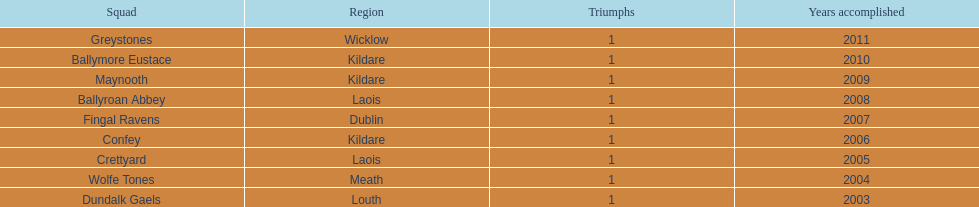How many wins does greystones have? 1. 